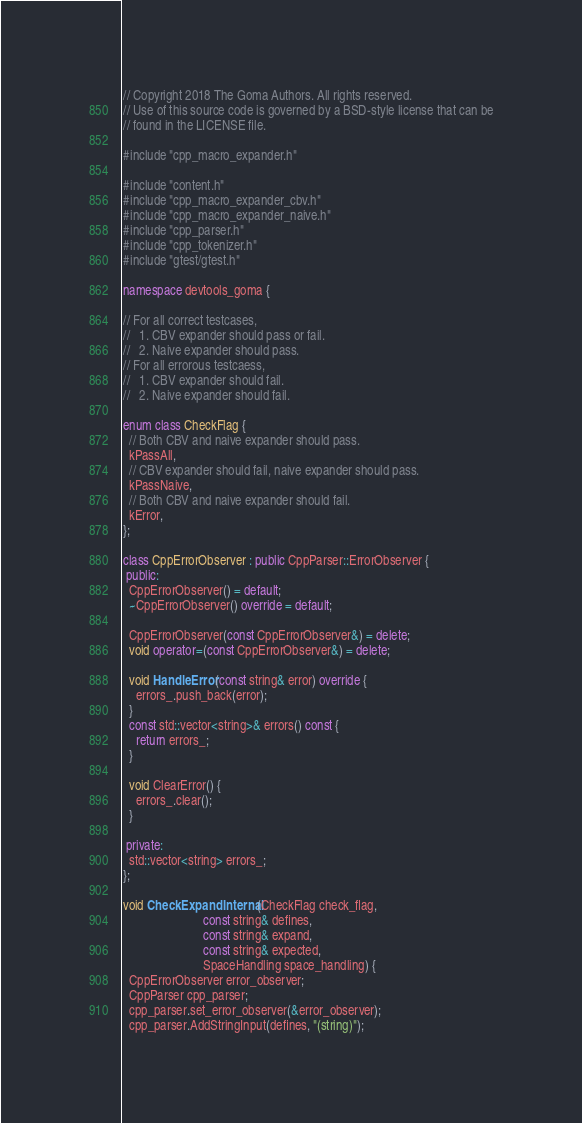<code> <loc_0><loc_0><loc_500><loc_500><_C++_>// Copyright 2018 The Goma Authors. All rights reserved.
// Use of this source code is governed by a BSD-style license that can be
// found in the LICENSE file.

#include "cpp_macro_expander.h"

#include "content.h"
#include "cpp_macro_expander_cbv.h"
#include "cpp_macro_expander_naive.h"
#include "cpp_parser.h"
#include "cpp_tokenizer.h"
#include "gtest/gtest.h"

namespace devtools_goma {

// For all correct testcases,
//   1. CBV expander should pass or fail.
//   2. Naive expander should pass.
// For all errorous testcaess,
//   1. CBV expander should fail.
//   2. Naive expander should fail.

enum class CheckFlag {
  // Both CBV and naive expander should pass.
  kPassAll,
  // CBV expander should fail, naive expander should pass.
  kPassNaive,
  // Both CBV and naive expander should fail.
  kError,
};

class CppErrorObserver : public CppParser::ErrorObserver {
 public:
  CppErrorObserver() = default;
  ~CppErrorObserver() override = default;

  CppErrorObserver(const CppErrorObserver&) = delete;
  void operator=(const CppErrorObserver&) = delete;

  void HandleError(const string& error) override {
    errors_.push_back(error);
  }
  const std::vector<string>& errors() const {
    return errors_;
  }

  void ClearError() {
    errors_.clear();
  }

 private:
  std::vector<string> errors_;
};

void CheckExpandInternal(CheckFlag check_flag,
                         const string& defines,
                         const string& expand,
                         const string& expected,
                         SpaceHandling space_handling) {
  CppErrorObserver error_observer;
  CppParser cpp_parser;
  cpp_parser.set_error_observer(&error_observer);
  cpp_parser.AddStringInput(defines, "(string)");</code> 